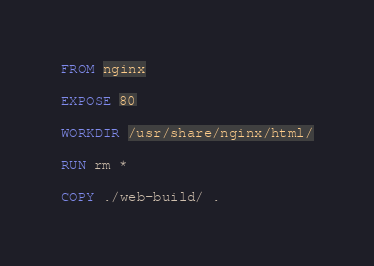Convert code to text. <code><loc_0><loc_0><loc_500><loc_500><_Dockerfile_>FROM nginx

EXPOSE 80

WORKDIR /usr/share/nginx/html/

RUN rm *

COPY ./web-build/ .
</code> 